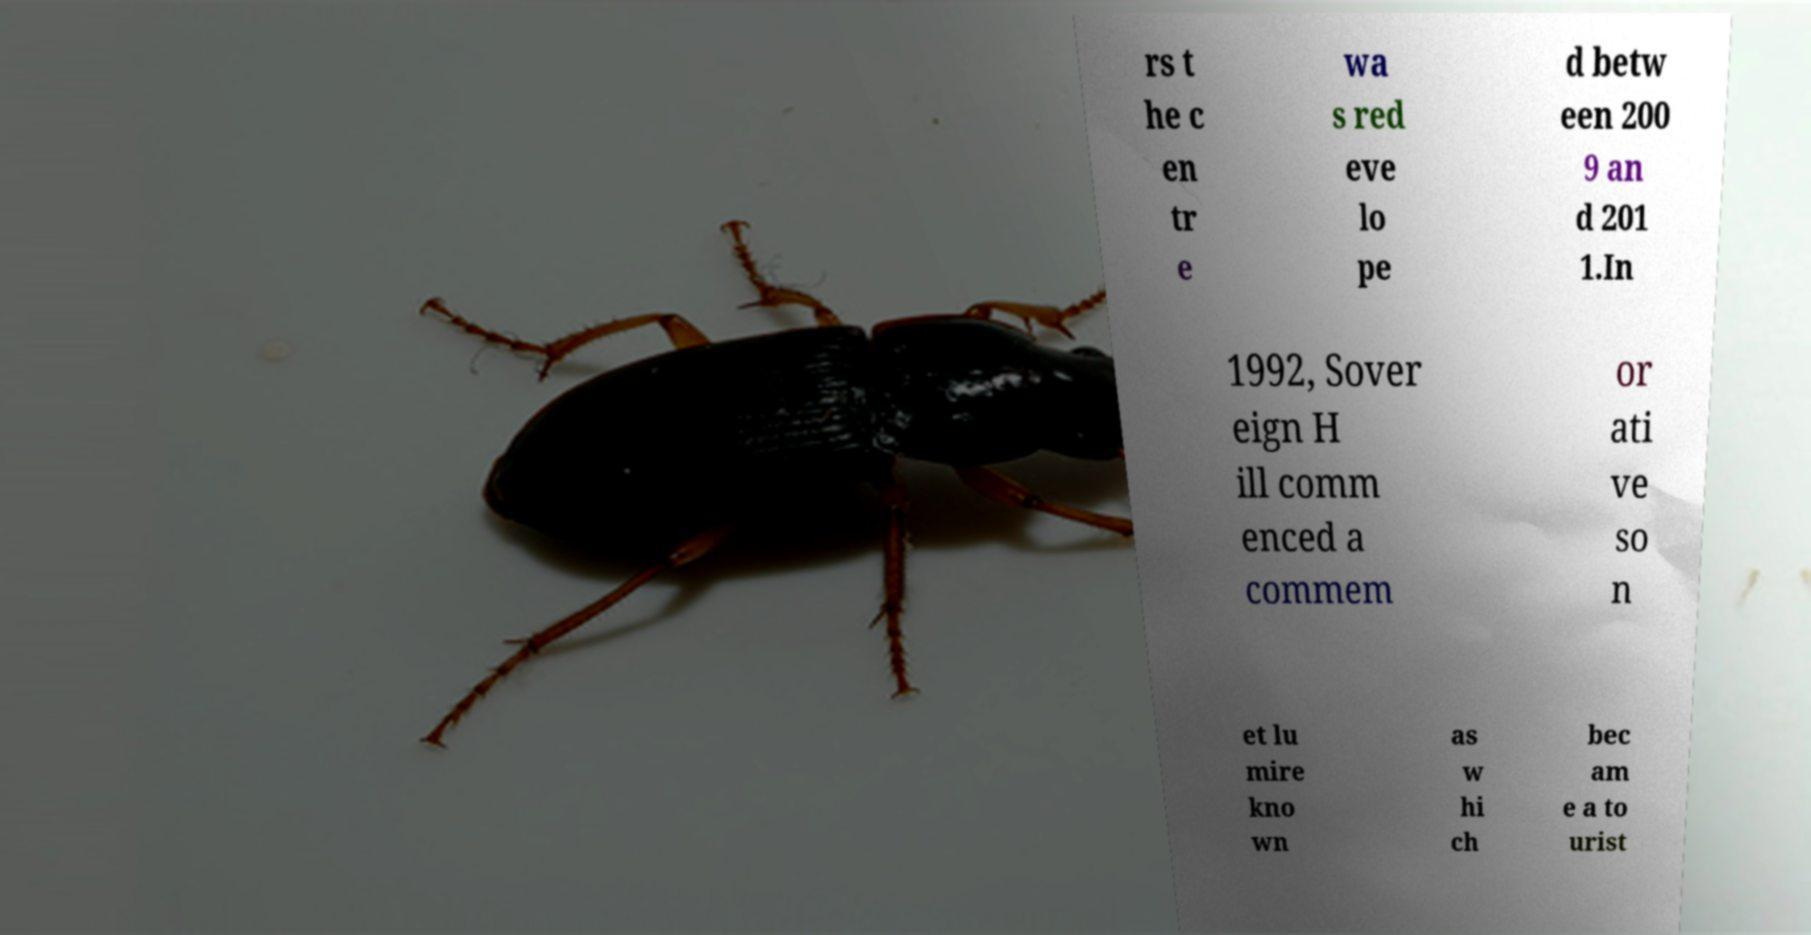What messages or text are displayed in this image? I need them in a readable, typed format. rs t he c en tr e wa s red eve lo pe d betw een 200 9 an d 201 1.In 1992, Sover eign H ill comm enced a commem or ati ve so n et lu mire kno wn as w hi ch bec am e a to urist 